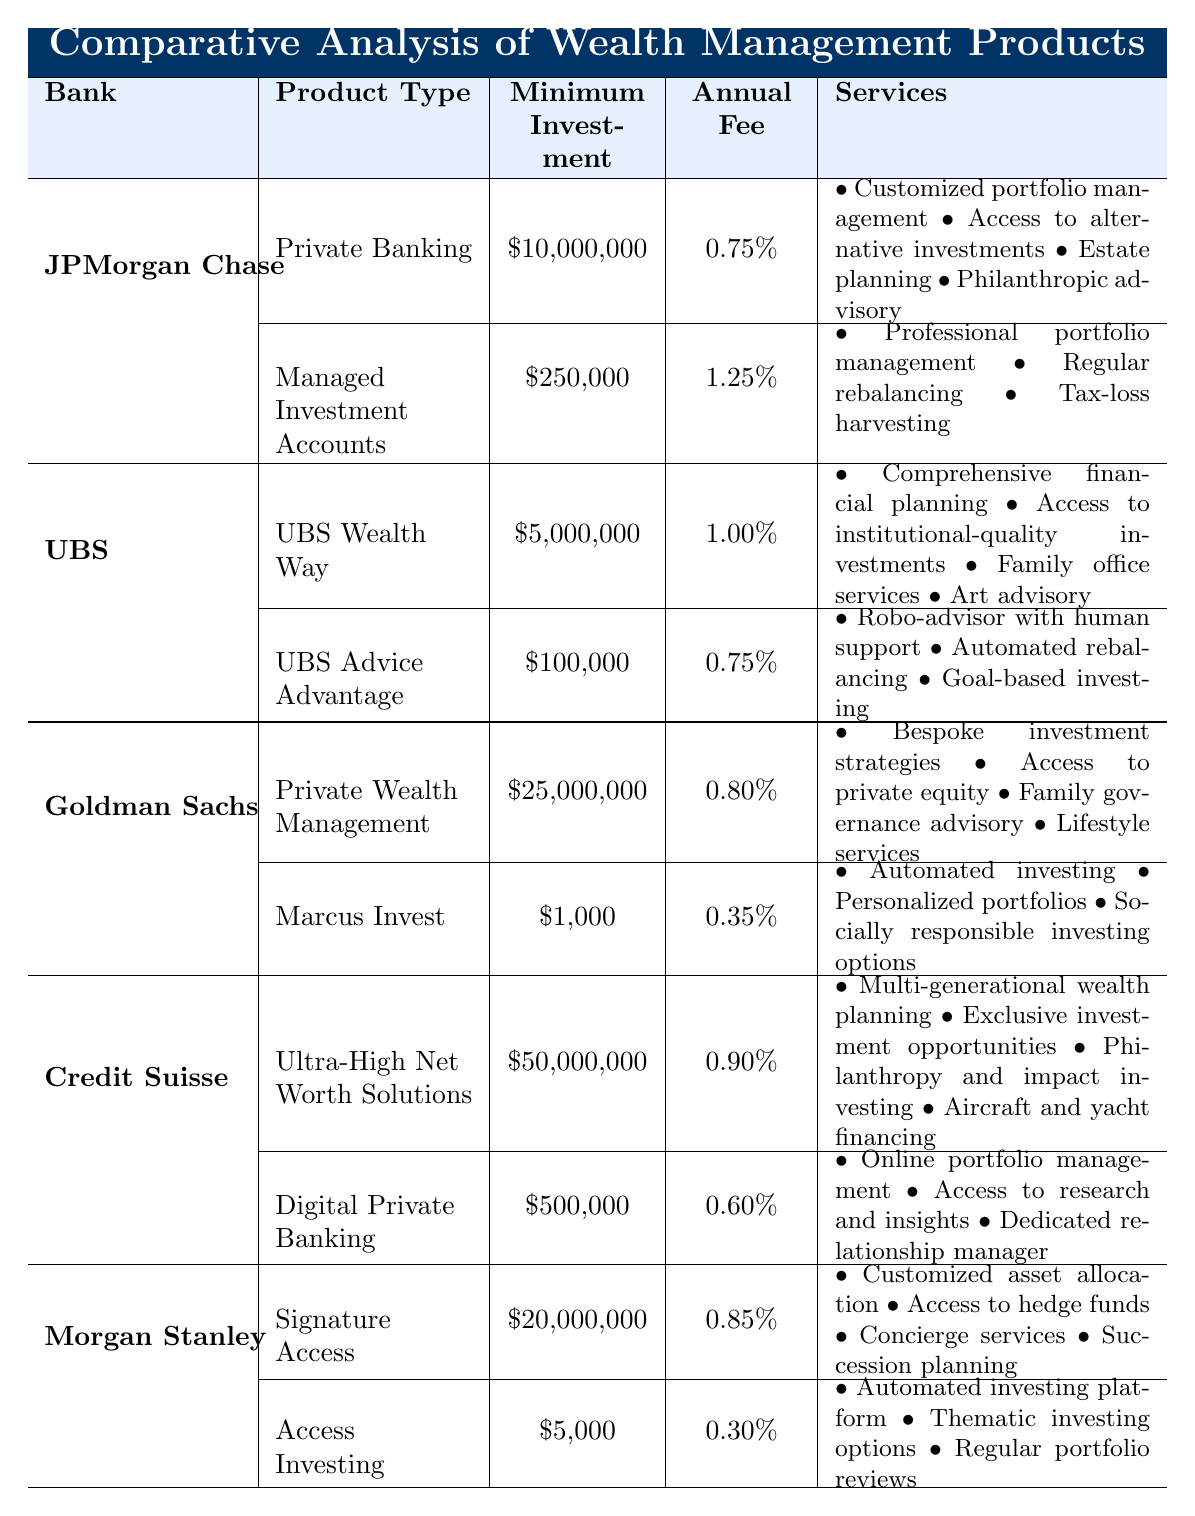What is the minimum investment required for UBS Wealth Way? The table lists UBS Wealth Way under UBS bank with a minimum investment amount specified as $5,000,000.
Answer: $5,000,000 Which bank offers the lowest annual fee for a wealth management product? By comparing the annual fees for all products in the table, Marcus Invest from Goldman Sachs has the lowest fee at 0.35%.
Answer: 0.35% How much higher is the minimum investment for Private Wealth Management at Goldman Sachs compared to Access Investing at Morgan Stanley? The minimum investment for Private Wealth Management is $25,000,000, and for Access Investing, it is $5,000. The difference is $25,000,000 - $5,000 = $24,995,000.
Answer: $24,995,000 Is there a wealth management product available with a minimum investment of less than $10,000? No product in the table has a minimum investment of less than $1,000, as the lowest is Marcus Invest with a minimum of $1,000.
Answer: No Which bank has a product that provides family office services, and what is the associated annual fee? The UBS Wealth Way product offers family office services, and it has an annual fee of 1.00%.
Answer: 1.00% What is the average annual fee of the products offered by Morgan Stanley? The two products from Morgan Stanley are Signature Access at 0.85% and Access Investing at 0.30%. The average is (0.85 + 0.30) / 2 = 0.575%.
Answer: 0.575% How many banks offer wealth management products with a minimum investment requirement of $10,000,000 or more? The banks with such products are JPMorgan Chase, Goldman Sachs, and Credit Suisse, totaling three banks.
Answer: 3 What services does the Digital Private Banking product from Credit Suisse offer? The services listed for Digital Private Banking include online portfolio management, access to research and insights, and a dedicated relationship manager.
Answer: Online portfolio management, access to research and insights, dedicated relationship manager Which product has the highest minimum investment requirement and what is it? The Ultra-High Net Worth Solutions from Credit Suisse has the highest minimum investment requirement of $50,000,000.
Answer: $50,000,000 Are philanthropic advisory services included in the JPMorgan Chase product offerings? Yes, the Private Banking product offered by JPMorgan Chase includes philanthropic advisory services as one of its offerings.
Answer: Yes 